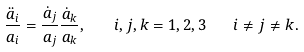<formula> <loc_0><loc_0><loc_500><loc_500>\frac { \ddot { a } _ { i } } { a _ { i } } = \frac { \dot { a } _ { j } } { a _ { j } } \frac { \dot { a } _ { k } } { a _ { k } } , \quad i , j , k = 1 , 2 , 3 \quad i \ne j \ne k .</formula> 